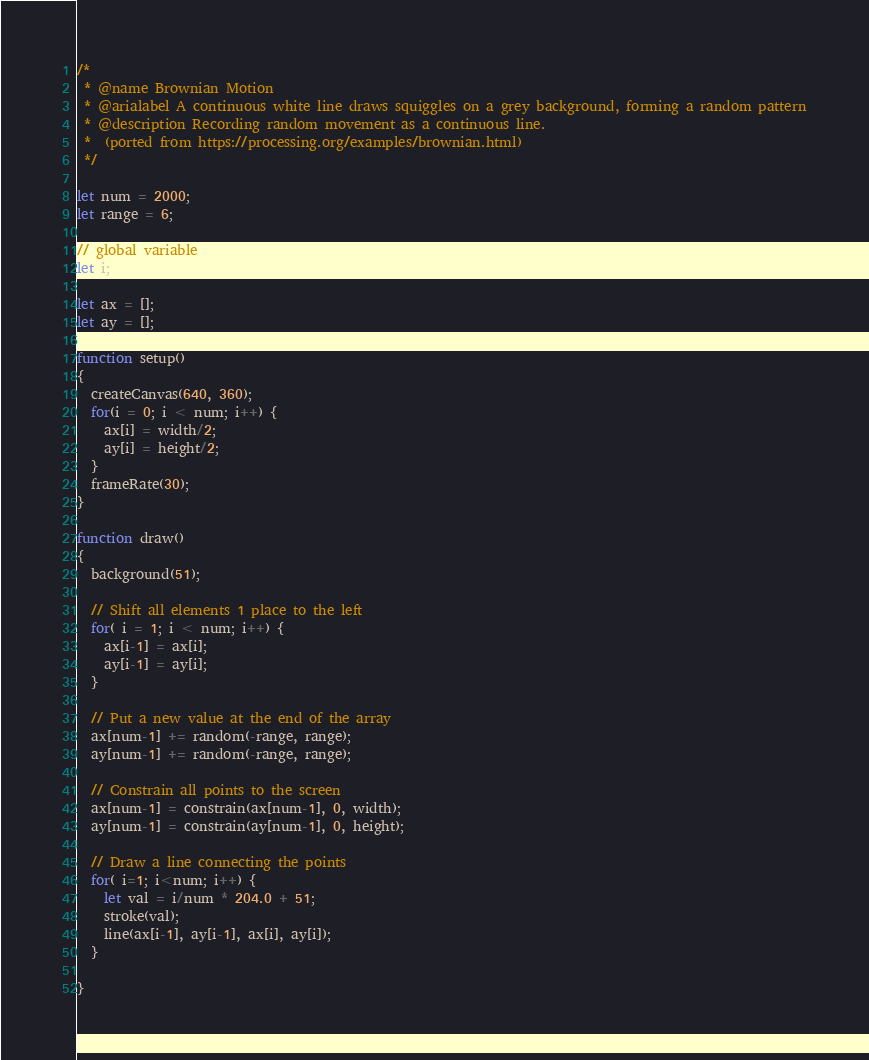Convert code to text. <code><loc_0><loc_0><loc_500><loc_500><_JavaScript_>/*
 * @name Brownian Motion
 * @arialabel A continuous white line draws squiggles on a grey background, forming a random pattern
 * @description Recording random movement as a continuous line.
 *  (ported from https://processing.org/examples/brownian.html)
 */

let num = 2000;
let range = 6;

// global variable 
let i;

let ax = [];
let ay = [];

function setup() 
{
  createCanvas(640, 360);
  for(i = 0; i < num; i++) {
    ax[i] = width/2;
    ay[i] = height/2;
  }
  frameRate(30);
}

function draw() 
{
  background(51);
  
  // Shift all elements 1 place to the left
  for( i = 1; i < num; i++) {
    ax[i-1] = ax[i];
    ay[i-1] = ay[i];
  }

  // Put a new value at the end of the array
  ax[num-1] += random(-range, range);
  ay[num-1] += random(-range, range);

  // Constrain all points to the screen
  ax[num-1] = constrain(ax[num-1], 0, width);
  ay[num-1] = constrain(ay[num-1], 0, height);
  
  // Draw a line connecting the points
  for( i=1; i<num; i++) {    
    let val = i/num * 204.0 + 51;
    stroke(val);
    line(ax[i-1], ay[i-1], ax[i], ay[i]);
  }
  
}

</code> 